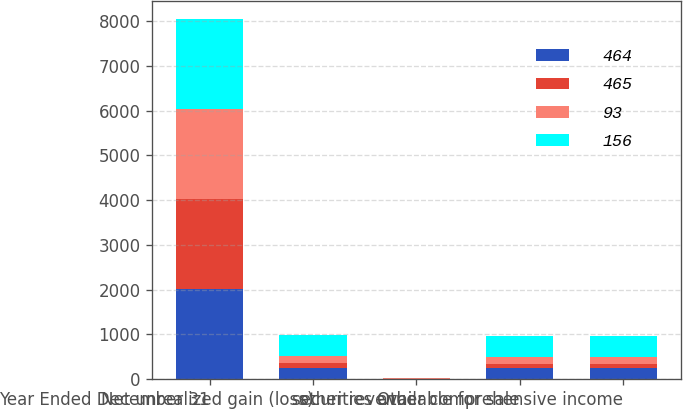<chart> <loc_0><loc_0><loc_500><loc_500><stacked_bar_chart><ecel><fcel>Year Ended December 31<fcel>Net unrealized gain (loss)<fcel>other revenue<fcel>securities available for sale<fcel>Other comprehensive income<nl><fcel>464<fcel>2014<fcel>255<fcel>7<fcel>249<fcel>249<nl><fcel>465<fcel>2014<fcel>95<fcel>3<fcel>93<fcel>93<nl><fcel>93<fcel>2014<fcel>160<fcel>4<fcel>156<fcel>156<nl><fcel>156<fcel>2013<fcel>468<fcel>7<fcel>465<fcel>464<nl></chart> 